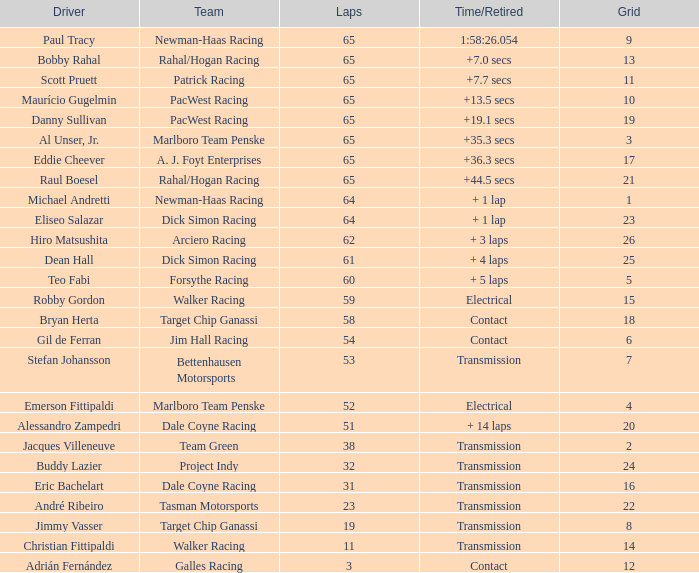For a time/retired of +19.1 seconds, what was the top grid spot? 19.0. 